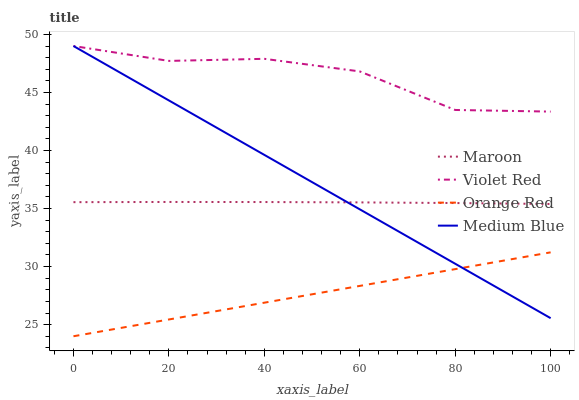Does Orange Red have the minimum area under the curve?
Answer yes or no. Yes. Does Violet Red have the maximum area under the curve?
Answer yes or no. Yes. Does Medium Blue have the minimum area under the curve?
Answer yes or no. No. Does Medium Blue have the maximum area under the curve?
Answer yes or no. No. Is Orange Red the smoothest?
Answer yes or no. Yes. Is Violet Red the roughest?
Answer yes or no. Yes. Is Medium Blue the smoothest?
Answer yes or no. No. Is Medium Blue the roughest?
Answer yes or no. No. Does Orange Red have the lowest value?
Answer yes or no. Yes. Does Medium Blue have the lowest value?
Answer yes or no. No. Does Medium Blue have the highest value?
Answer yes or no. Yes. Does Orange Red have the highest value?
Answer yes or no. No. Is Orange Red less than Maroon?
Answer yes or no. Yes. Is Maroon greater than Orange Red?
Answer yes or no. Yes. Does Medium Blue intersect Orange Red?
Answer yes or no. Yes. Is Medium Blue less than Orange Red?
Answer yes or no. No. Is Medium Blue greater than Orange Red?
Answer yes or no. No. Does Orange Red intersect Maroon?
Answer yes or no. No. 